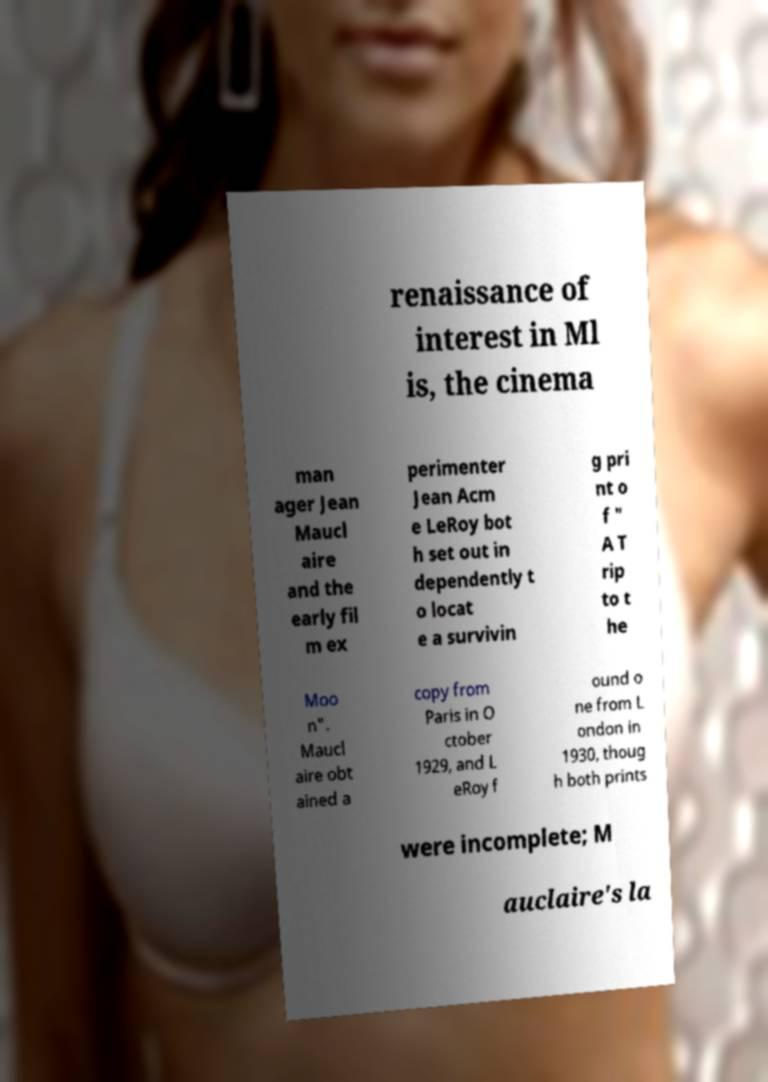I need the written content from this picture converted into text. Can you do that? renaissance of interest in Ml is, the cinema man ager Jean Maucl aire and the early fil m ex perimenter Jean Acm e LeRoy bot h set out in dependently t o locat e a survivin g pri nt o f " A T rip to t he Moo n". Maucl aire obt ained a copy from Paris in O ctober 1929, and L eRoy f ound o ne from L ondon in 1930, thoug h both prints were incomplete; M auclaire's la 